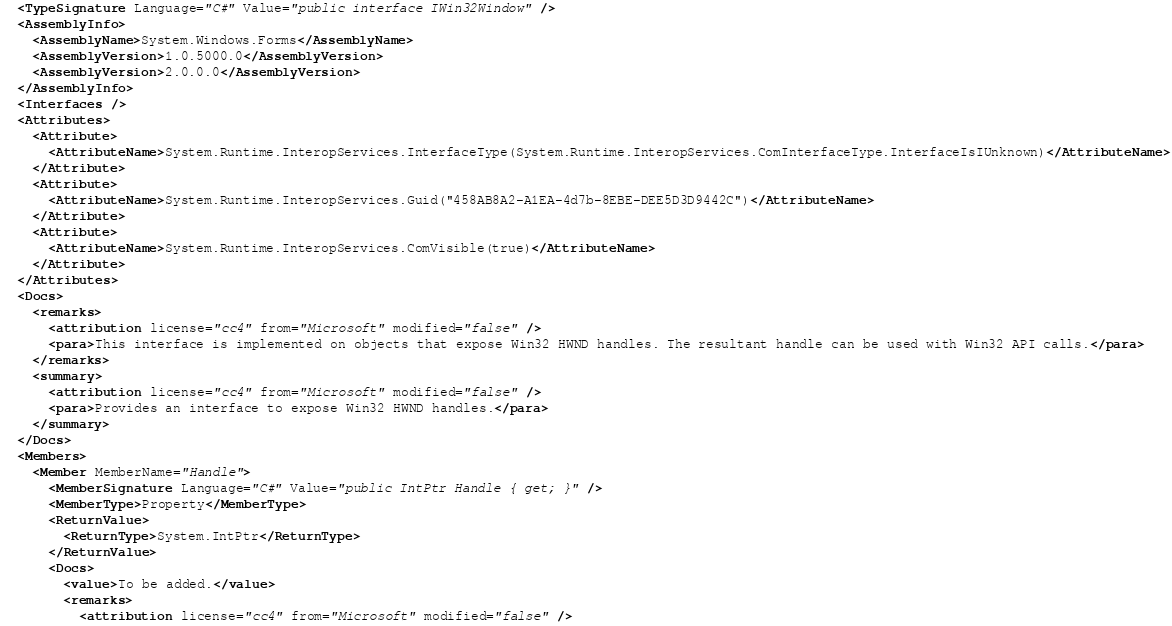Convert code to text. <code><loc_0><loc_0><loc_500><loc_500><_XML_>  <TypeSignature Language="C#" Value="public interface IWin32Window" />
  <AssemblyInfo>
    <AssemblyName>System.Windows.Forms</AssemblyName>
    <AssemblyVersion>1.0.5000.0</AssemblyVersion>
    <AssemblyVersion>2.0.0.0</AssemblyVersion>
  </AssemblyInfo>
  <Interfaces />
  <Attributes>
    <Attribute>
      <AttributeName>System.Runtime.InteropServices.InterfaceType(System.Runtime.InteropServices.ComInterfaceType.InterfaceIsIUnknown)</AttributeName>
    </Attribute>
    <Attribute>
      <AttributeName>System.Runtime.InteropServices.Guid("458AB8A2-A1EA-4d7b-8EBE-DEE5D3D9442C")</AttributeName>
    </Attribute>
    <Attribute>
      <AttributeName>System.Runtime.InteropServices.ComVisible(true)</AttributeName>
    </Attribute>
  </Attributes>
  <Docs>
    <remarks>
      <attribution license="cc4" from="Microsoft" modified="false" />
      <para>This interface is implemented on objects that expose Win32 HWND handles. The resultant handle can be used with Win32 API calls.</para>
    </remarks>
    <summary>
      <attribution license="cc4" from="Microsoft" modified="false" />
      <para>Provides an interface to expose Win32 HWND handles.</para>
    </summary>
  </Docs>
  <Members>
    <Member MemberName="Handle">
      <MemberSignature Language="C#" Value="public IntPtr Handle { get; }" />
      <MemberType>Property</MemberType>
      <ReturnValue>
        <ReturnType>System.IntPtr</ReturnType>
      </ReturnValue>
      <Docs>
        <value>To be added.</value>
        <remarks>
          <attribution license="cc4" from="Microsoft" modified="false" /></code> 